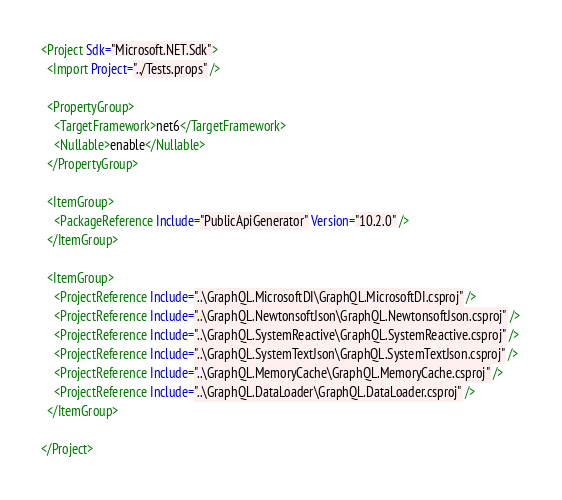<code> <loc_0><loc_0><loc_500><loc_500><_XML_><Project Sdk="Microsoft.NET.Sdk">
  <Import Project="../Tests.props" />

  <PropertyGroup>
    <TargetFramework>net6</TargetFramework>
    <Nullable>enable</Nullable>
  </PropertyGroup>

  <ItemGroup>
    <PackageReference Include="PublicApiGenerator" Version="10.2.0" />
  </ItemGroup>

  <ItemGroup>
    <ProjectReference Include="..\GraphQL.MicrosoftDI\GraphQL.MicrosoftDI.csproj" />
    <ProjectReference Include="..\GraphQL.NewtonsoftJson\GraphQL.NewtonsoftJson.csproj" />
    <ProjectReference Include="..\GraphQL.SystemReactive\GraphQL.SystemReactive.csproj" />
    <ProjectReference Include="..\GraphQL.SystemTextJson\GraphQL.SystemTextJson.csproj" />
    <ProjectReference Include="..\GraphQL.MemoryCache\GraphQL.MemoryCache.csproj" />
    <ProjectReference Include="..\GraphQL.DataLoader\GraphQL.DataLoader.csproj" />
  </ItemGroup>

</Project>
</code> 